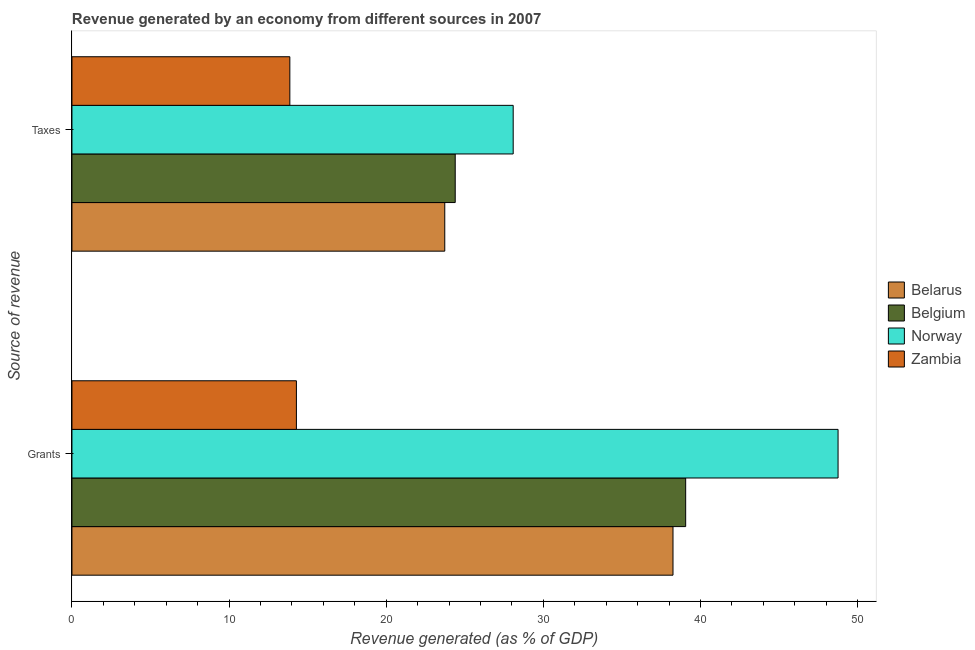How many groups of bars are there?
Offer a very short reply. 2. Are the number of bars per tick equal to the number of legend labels?
Give a very brief answer. Yes. Are the number of bars on each tick of the Y-axis equal?
Provide a succinct answer. Yes. How many bars are there on the 1st tick from the top?
Offer a very short reply. 4. What is the label of the 1st group of bars from the top?
Provide a succinct answer. Taxes. What is the revenue generated by taxes in Zambia?
Your response must be concise. 13.87. Across all countries, what is the maximum revenue generated by grants?
Your answer should be compact. 48.76. Across all countries, what is the minimum revenue generated by grants?
Offer a very short reply. 14.28. In which country was the revenue generated by grants maximum?
Your answer should be compact. Norway. In which country was the revenue generated by taxes minimum?
Provide a succinct answer. Zambia. What is the total revenue generated by taxes in the graph?
Give a very brief answer. 90.07. What is the difference between the revenue generated by grants in Zambia and that in Belgium?
Provide a short and direct response. -24.77. What is the difference between the revenue generated by taxes in Zambia and the revenue generated by grants in Belgium?
Your answer should be compact. -25.19. What is the average revenue generated by grants per country?
Provide a succinct answer. 35.09. What is the difference between the revenue generated by taxes and revenue generated by grants in Zambia?
Your answer should be very brief. -0.42. What is the ratio of the revenue generated by grants in Belgium to that in Belarus?
Your response must be concise. 1.02. Is the revenue generated by grants in Zambia less than that in Belarus?
Offer a very short reply. Yes. In how many countries, is the revenue generated by taxes greater than the average revenue generated by taxes taken over all countries?
Ensure brevity in your answer.  3. What does the 4th bar from the top in Grants represents?
Offer a terse response. Belarus. What does the 3rd bar from the bottom in Grants represents?
Ensure brevity in your answer.  Norway. How many bars are there?
Offer a very short reply. 8. How many countries are there in the graph?
Your answer should be compact. 4. What is the difference between two consecutive major ticks on the X-axis?
Your response must be concise. 10. Are the values on the major ticks of X-axis written in scientific E-notation?
Offer a very short reply. No. Does the graph contain grids?
Your answer should be compact. No. Where does the legend appear in the graph?
Your response must be concise. Center right. How many legend labels are there?
Provide a short and direct response. 4. How are the legend labels stacked?
Your answer should be compact. Vertical. What is the title of the graph?
Ensure brevity in your answer.  Revenue generated by an economy from different sources in 2007. What is the label or title of the X-axis?
Ensure brevity in your answer.  Revenue generated (as % of GDP). What is the label or title of the Y-axis?
Offer a terse response. Source of revenue. What is the Revenue generated (as % of GDP) in Belarus in Grants?
Your response must be concise. 38.25. What is the Revenue generated (as % of GDP) in Belgium in Grants?
Give a very brief answer. 39.06. What is the Revenue generated (as % of GDP) of Norway in Grants?
Provide a succinct answer. 48.76. What is the Revenue generated (as % of GDP) of Zambia in Grants?
Give a very brief answer. 14.28. What is the Revenue generated (as % of GDP) in Belarus in Taxes?
Give a very brief answer. 23.73. What is the Revenue generated (as % of GDP) in Belgium in Taxes?
Provide a succinct answer. 24.39. What is the Revenue generated (as % of GDP) of Norway in Taxes?
Give a very brief answer. 28.08. What is the Revenue generated (as % of GDP) of Zambia in Taxes?
Ensure brevity in your answer.  13.87. Across all Source of revenue, what is the maximum Revenue generated (as % of GDP) in Belarus?
Provide a succinct answer. 38.25. Across all Source of revenue, what is the maximum Revenue generated (as % of GDP) in Belgium?
Offer a terse response. 39.06. Across all Source of revenue, what is the maximum Revenue generated (as % of GDP) of Norway?
Keep it short and to the point. 48.76. Across all Source of revenue, what is the maximum Revenue generated (as % of GDP) in Zambia?
Ensure brevity in your answer.  14.28. Across all Source of revenue, what is the minimum Revenue generated (as % of GDP) of Belarus?
Provide a succinct answer. 23.73. Across all Source of revenue, what is the minimum Revenue generated (as % of GDP) of Belgium?
Provide a succinct answer. 24.39. Across all Source of revenue, what is the minimum Revenue generated (as % of GDP) in Norway?
Provide a succinct answer. 28.08. Across all Source of revenue, what is the minimum Revenue generated (as % of GDP) of Zambia?
Give a very brief answer. 13.87. What is the total Revenue generated (as % of GDP) in Belarus in the graph?
Offer a terse response. 61.98. What is the total Revenue generated (as % of GDP) in Belgium in the graph?
Keep it short and to the point. 63.45. What is the total Revenue generated (as % of GDP) of Norway in the graph?
Provide a succinct answer. 76.84. What is the total Revenue generated (as % of GDP) in Zambia in the graph?
Keep it short and to the point. 28.15. What is the difference between the Revenue generated (as % of GDP) of Belarus in Grants and that in Taxes?
Provide a short and direct response. 14.52. What is the difference between the Revenue generated (as % of GDP) of Belgium in Grants and that in Taxes?
Keep it short and to the point. 14.67. What is the difference between the Revenue generated (as % of GDP) of Norway in Grants and that in Taxes?
Provide a short and direct response. 20.67. What is the difference between the Revenue generated (as % of GDP) of Zambia in Grants and that in Taxes?
Make the answer very short. 0.42. What is the difference between the Revenue generated (as % of GDP) in Belarus in Grants and the Revenue generated (as % of GDP) in Belgium in Taxes?
Provide a succinct answer. 13.86. What is the difference between the Revenue generated (as % of GDP) in Belarus in Grants and the Revenue generated (as % of GDP) in Norway in Taxes?
Make the answer very short. 10.17. What is the difference between the Revenue generated (as % of GDP) of Belarus in Grants and the Revenue generated (as % of GDP) of Zambia in Taxes?
Keep it short and to the point. 24.38. What is the difference between the Revenue generated (as % of GDP) in Belgium in Grants and the Revenue generated (as % of GDP) in Norway in Taxes?
Your answer should be very brief. 10.98. What is the difference between the Revenue generated (as % of GDP) of Belgium in Grants and the Revenue generated (as % of GDP) of Zambia in Taxes?
Your response must be concise. 25.19. What is the difference between the Revenue generated (as % of GDP) of Norway in Grants and the Revenue generated (as % of GDP) of Zambia in Taxes?
Your answer should be very brief. 34.89. What is the average Revenue generated (as % of GDP) in Belarus per Source of revenue?
Your response must be concise. 30.99. What is the average Revenue generated (as % of GDP) of Belgium per Source of revenue?
Keep it short and to the point. 31.72. What is the average Revenue generated (as % of GDP) in Norway per Source of revenue?
Your answer should be compact. 38.42. What is the average Revenue generated (as % of GDP) in Zambia per Source of revenue?
Keep it short and to the point. 14.08. What is the difference between the Revenue generated (as % of GDP) of Belarus and Revenue generated (as % of GDP) of Belgium in Grants?
Ensure brevity in your answer.  -0.81. What is the difference between the Revenue generated (as % of GDP) in Belarus and Revenue generated (as % of GDP) in Norway in Grants?
Offer a very short reply. -10.5. What is the difference between the Revenue generated (as % of GDP) of Belarus and Revenue generated (as % of GDP) of Zambia in Grants?
Make the answer very short. 23.97. What is the difference between the Revenue generated (as % of GDP) of Belgium and Revenue generated (as % of GDP) of Norway in Grants?
Offer a terse response. -9.7. What is the difference between the Revenue generated (as % of GDP) of Belgium and Revenue generated (as % of GDP) of Zambia in Grants?
Ensure brevity in your answer.  24.77. What is the difference between the Revenue generated (as % of GDP) in Norway and Revenue generated (as % of GDP) in Zambia in Grants?
Give a very brief answer. 34.47. What is the difference between the Revenue generated (as % of GDP) of Belarus and Revenue generated (as % of GDP) of Belgium in Taxes?
Your answer should be compact. -0.67. What is the difference between the Revenue generated (as % of GDP) of Belarus and Revenue generated (as % of GDP) of Norway in Taxes?
Your response must be concise. -4.35. What is the difference between the Revenue generated (as % of GDP) in Belarus and Revenue generated (as % of GDP) in Zambia in Taxes?
Provide a succinct answer. 9.86. What is the difference between the Revenue generated (as % of GDP) of Belgium and Revenue generated (as % of GDP) of Norway in Taxes?
Offer a terse response. -3.69. What is the difference between the Revenue generated (as % of GDP) in Belgium and Revenue generated (as % of GDP) in Zambia in Taxes?
Provide a succinct answer. 10.52. What is the difference between the Revenue generated (as % of GDP) of Norway and Revenue generated (as % of GDP) of Zambia in Taxes?
Your answer should be very brief. 14.21. What is the ratio of the Revenue generated (as % of GDP) in Belarus in Grants to that in Taxes?
Keep it short and to the point. 1.61. What is the ratio of the Revenue generated (as % of GDP) of Belgium in Grants to that in Taxes?
Your answer should be very brief. 1.6. What is the ratio of the Revenue generated (as % of GDP) in Norway in Grants to that in Taxes?
Provide a succinct answer. 1.74. What is the ratio of the Revenue generated (as % of GDP) of Zambia in Grants to that in Taxes?
Keep it short and to the point. 1.03. What is the difference between the highest and the second highest Revenue generated (as % of GDP) of Belarus?
Provide a succinct answer. 14.52. What is the difference between the highest and the second highest Revenue generated (as % of GDP) of Belgium?
Your answer should be compact. 14.67. What is the difference between the highest and the second highest Revenue generated (as % of GDP) in Norway?
Your answer should be very brief. 20.67. What is the difference between the highest and the second highest Revenue generated (as % of GDP) of Zambia?
Provide a succinct answer. 0.42. What is the difference between the highest and the lowest Revenue generated (as % of GDP) of Belarus?
Ensure brevity in your answer.  14.52. What is the difference between the highest and the lowest Revenue generated (as % of GDP) of Belgium?
Offer a terse response. 14.67. What is the difference between the highest and the lowest Revenue generated (as % of GDP) in Norway?
Offer a terse response. 20.67. What is the difference between the highest and the lowest Revenue generated (as % of GDP) in Zambia?
Your response must be concise. 0.42. 